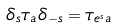<formula> <loc_0><loc_0><loc_500><loc_500>\delta _ { s } \tau _ { a } \delta _ { - s } = \tau _ { e ^ { s } a }</formula> 